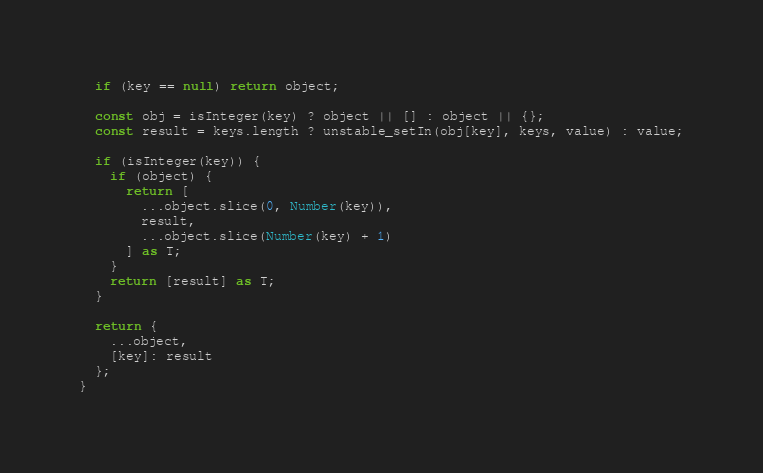<code> <loc_0><loc_0><loc_500><loc_500><_TypeScript_>  if (key == null) return object;

  const obj = isInteger(key) ? object || [] : object || {};
  const result = keys.length ? unstable_setIn(obj[key], keys, value) : value;

  if (isInteger(key)) {
    if (object) {
      return [
        ...object.slice(0, Number(key)),
        result,
        ...object.slice(Number(key) + 1)
      ] as T;
    }
    return [result] as T;
  }

  return {
    ...object,
    [key]: result
  };
}
</code> 